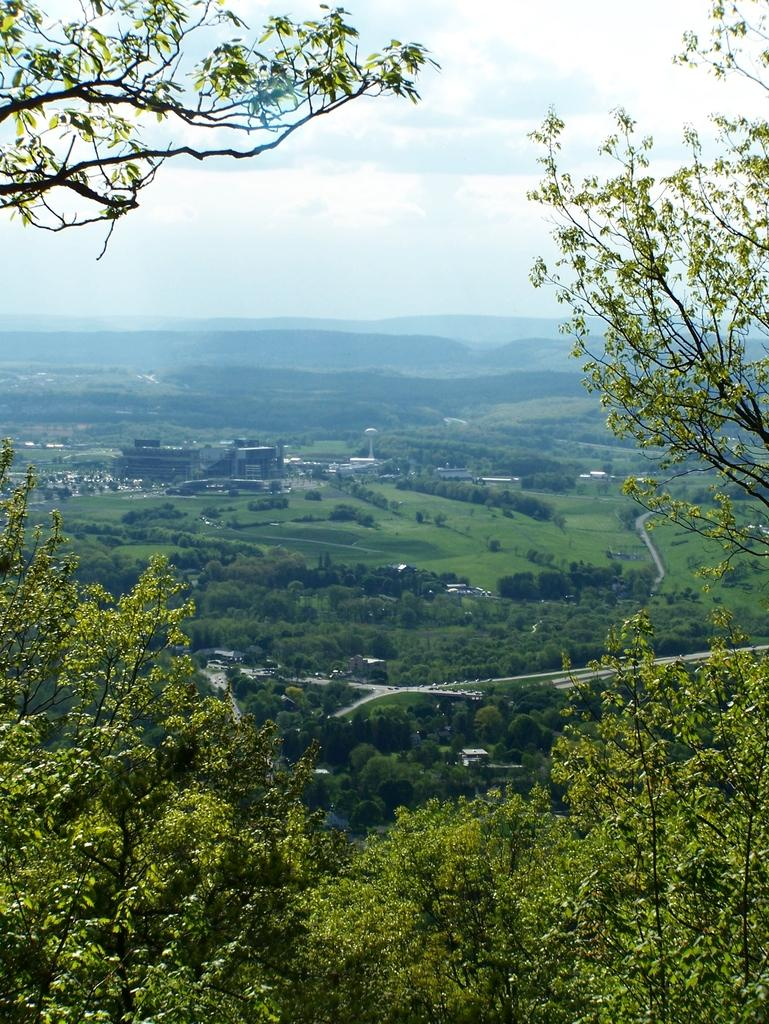What can be seen in the foreground of the image? In the foreground of the image, there are trees, vehicles, and grass. What type of structures are present in the image? There are houses and buildings in the image. What are the vertical structures visible in the image? Poles are visible in the image. What is the natural landscape feature in the image? Mountains are present in the image. What is visible at the top of the image? The sky is visible at the top of the image. Can we determine the time of day the image was taken? The image might have been taken during the day, based on the visibility of the sky and the presence of sunlight. What type of interest can be seen growing on the trees in the image? There is no mention of any interest growing on the trees in the image. Can you spot a toad sitting on the tray in the image? There is no tray or toad present in the image. 